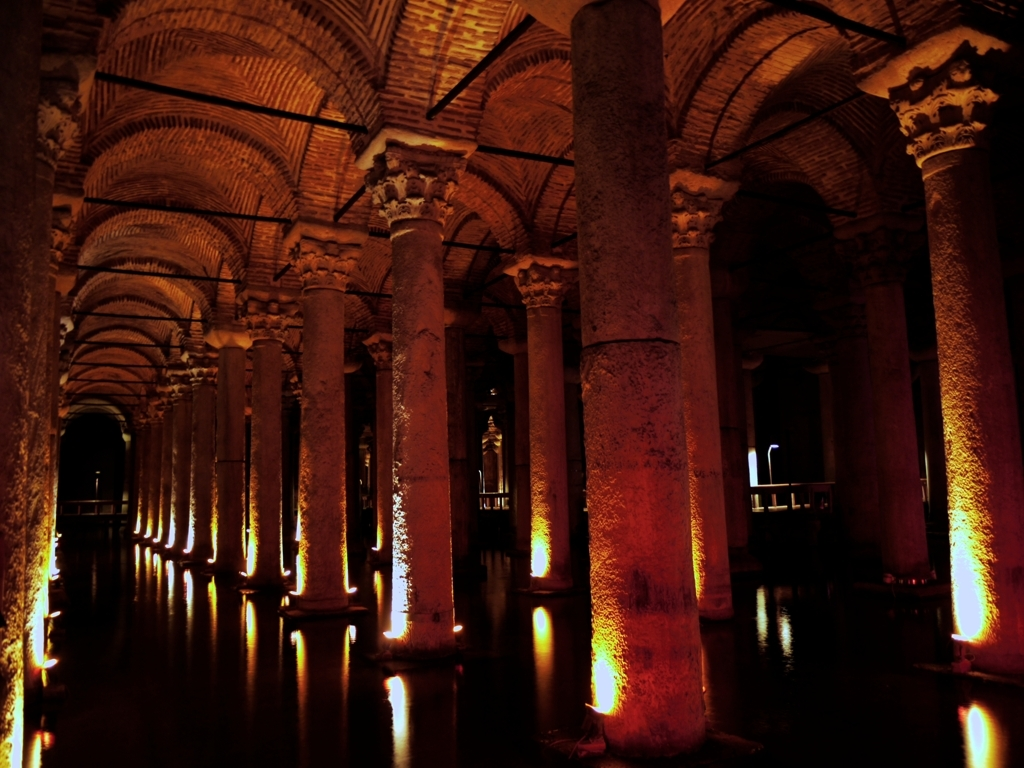What is the historical significance of this location? This location appears to be an ancient cistern or underground structure with a long history. It may have been used to store water for a city or palace, indicating an advanced level of civil engineering and cultural importance in its time. 